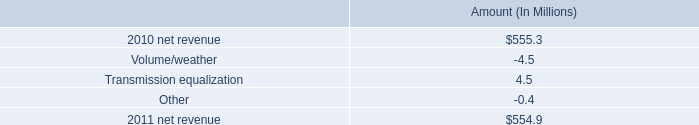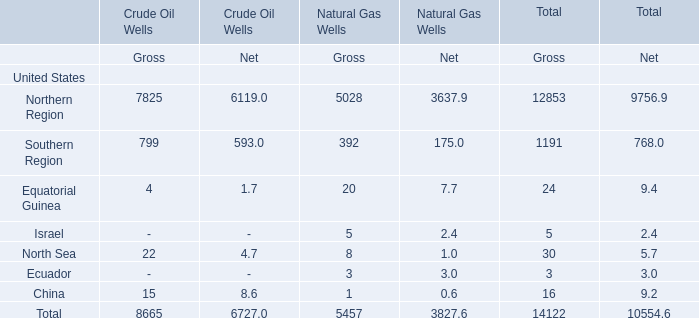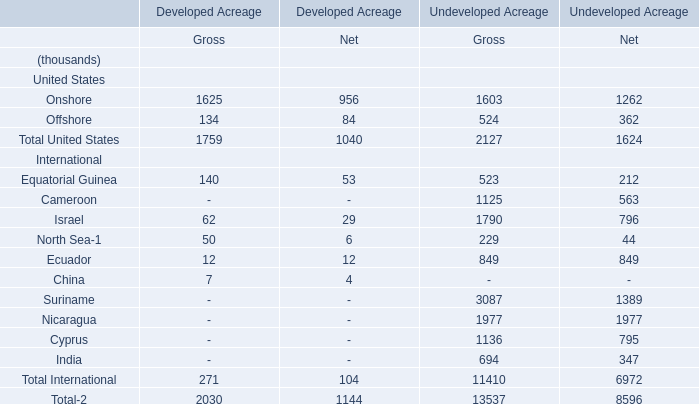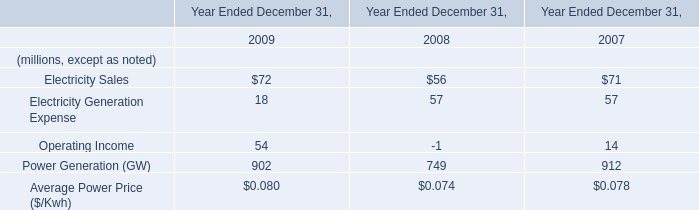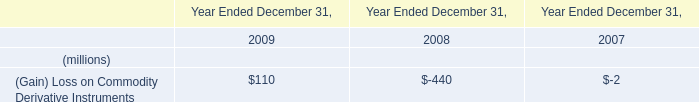what's the total amount of Northern Region of Crude Oil Wells Net, and Suriname International of Undeveloped Acreage Gross ? 
Computations: (6119.0 + 3087.0)
Answer: 9206.0. 